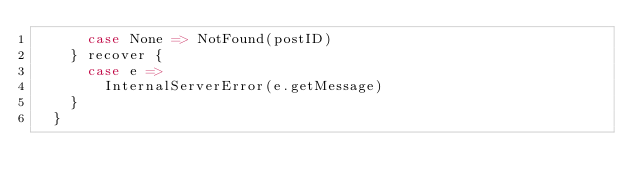Convert code to text. <code><loc_0><loc_0><loc_500><loc_500><_Scala_>      case None => NotFound(postID)
    } recover {
      case e =>
        InternalServerError(e.getMessage)
    }
  }
</code> 